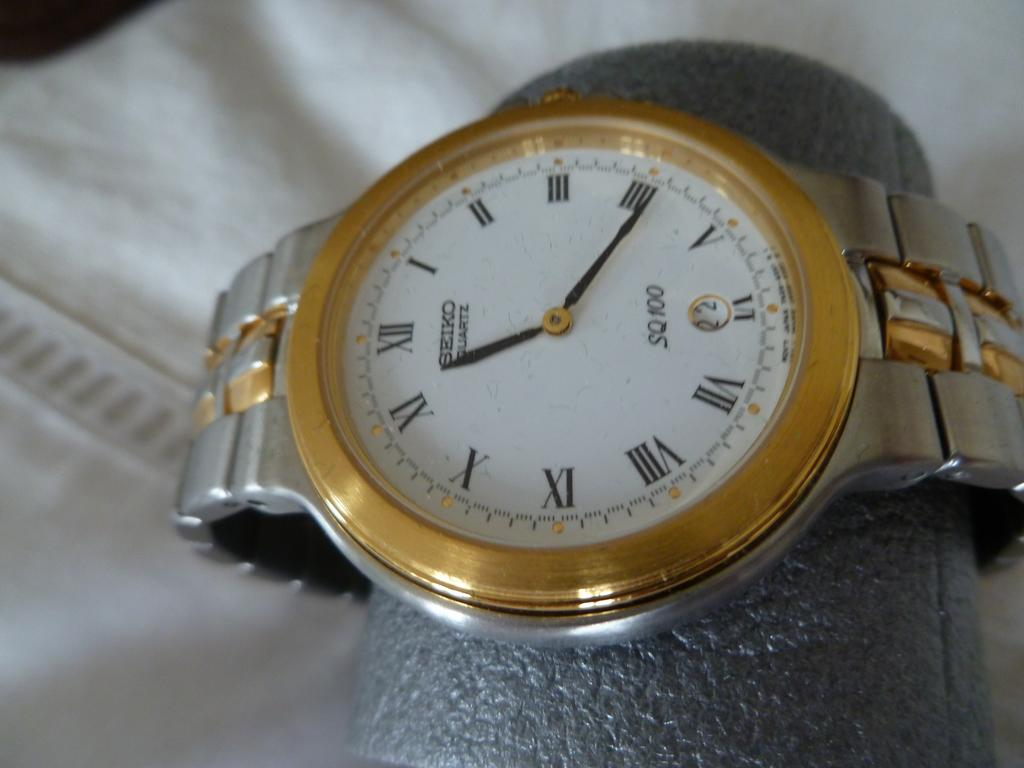<image>
Offer a succinct explanation of the picture presented. A gold and silver watch made by the brand Seiko. 